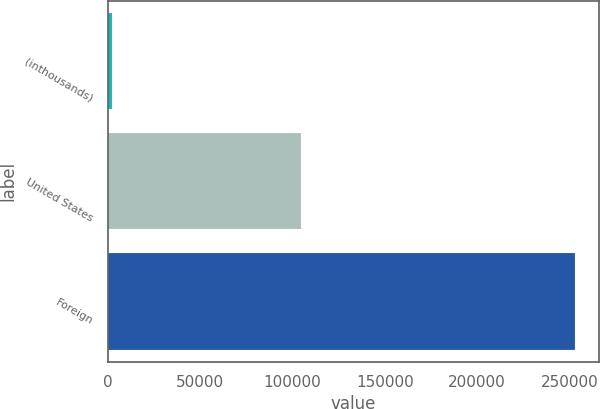Convert chart to OTSL. <chart><loc_0><loc_0><loc_500><loc_500><bar_chart><fcel>(inthousands)<fcel>United States<fcel>Foreign<nl><fcel>2010<fcel>104424<fcel>253232<nl></chart> 